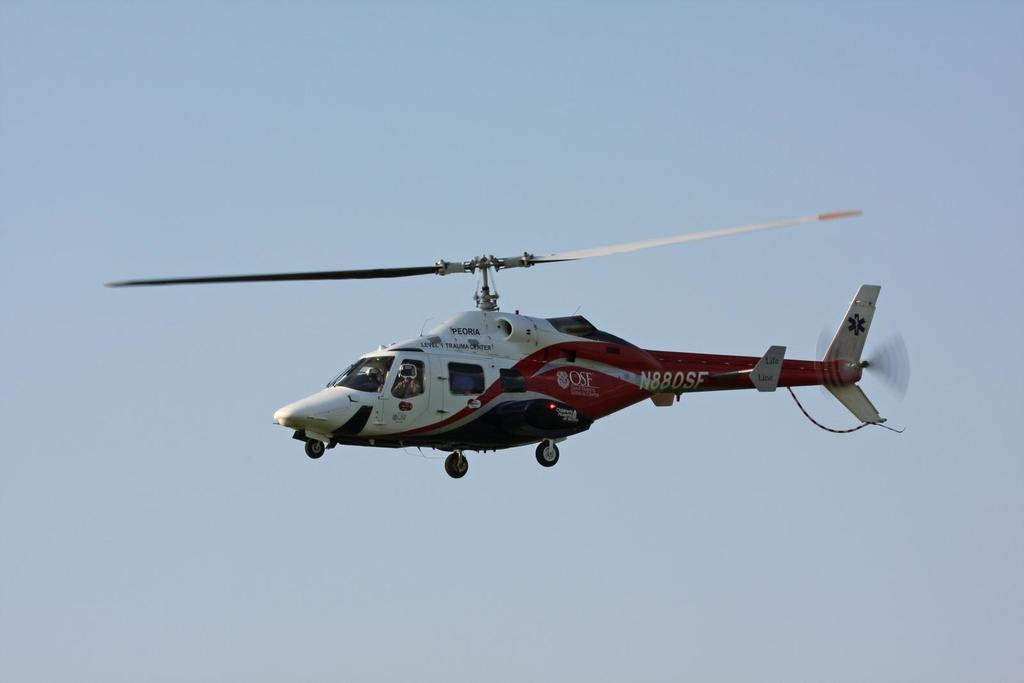What is the main subject in the foreground of the image? There is a helicopter in the foreground of the image. What is the helicopter doing in the image? The helicopter is in the air. What can be seen in the background of the image? The sky is visible in the background of the image. Can you see any sidewalks in the image? There are no sidewalks present in the image. What type of airplane is flying alongside the helicopter in the image? There is no airplane present in the image; only the helicopter is visible. 